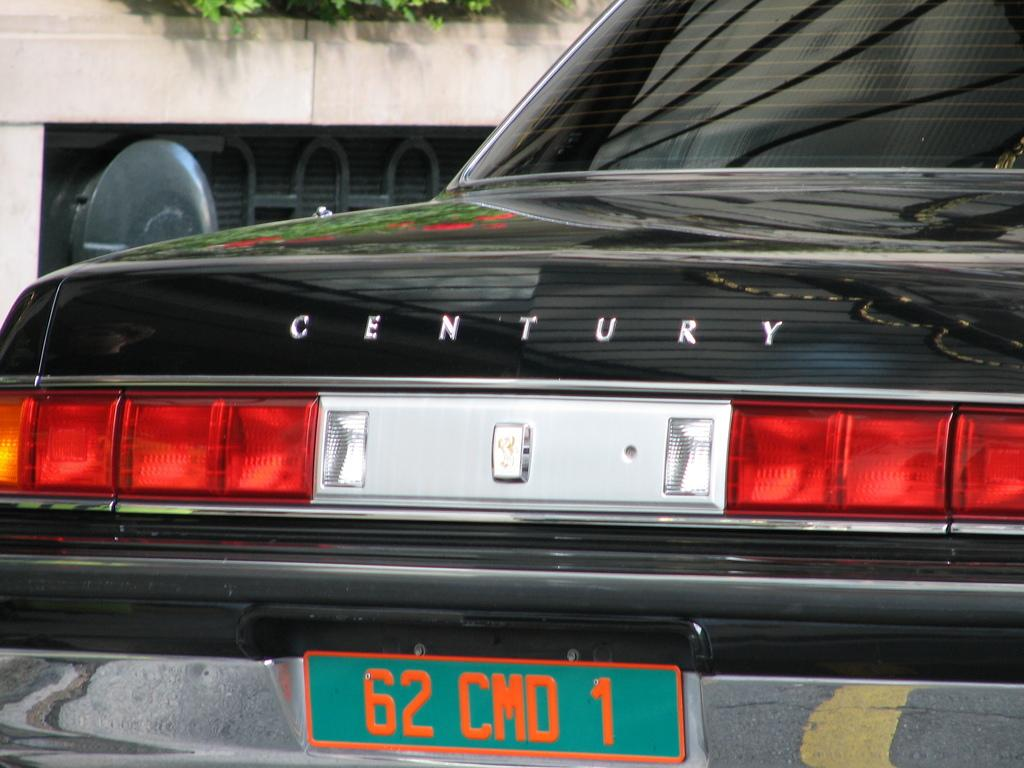What part of a car can be seen in the image? The back part of a car is visible in the image. What is located behind the car in the image? There is a building behind the car in the image. Are there any natural elements present in the image? Yes, plants are present in the image. How many holes can be seen in the car's body in the image? There are no visible holes in the car's body in the image. Who is the friend of the person driving the car in the image? There is no information about the driver or any friends in the image. 